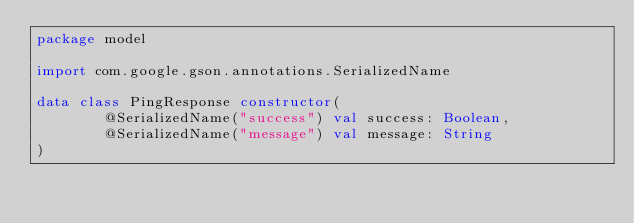Convert code to text. <code><loc_0><loc_0><loc_500><loc_500><_Kotlin_>package model

import com.google.gson.annotations.SerializedName

data class PingResponse constructor(
        @SerializedName("success") val success: Boolean,
        @SerializedName("message") val message: String
)</code> 